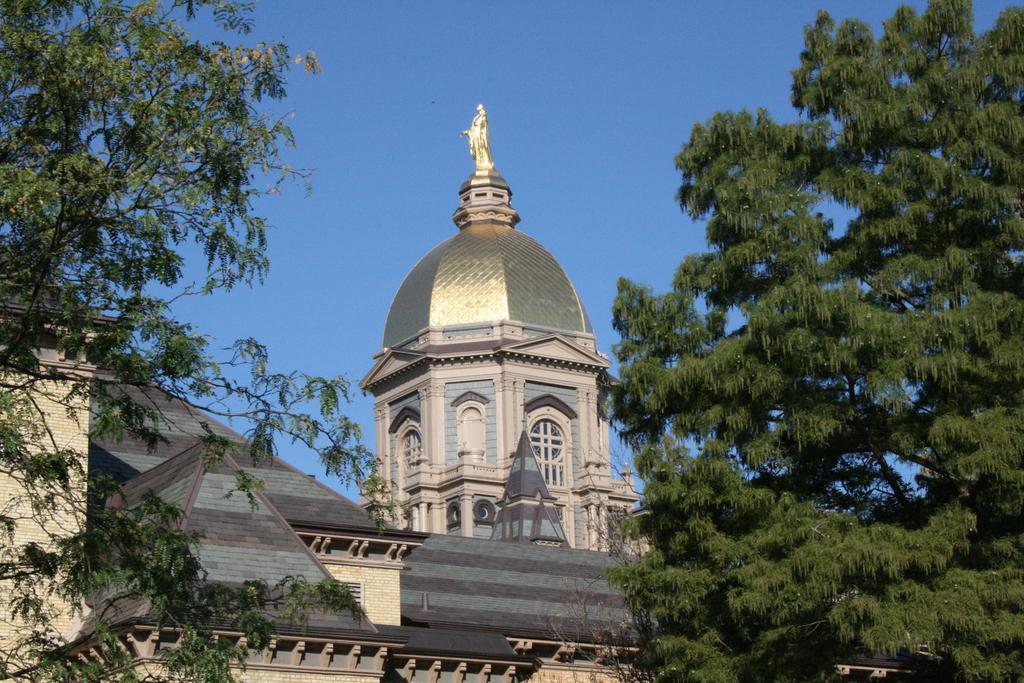Please provide a concise description of this image. This is a building, these are trees and a sky. 